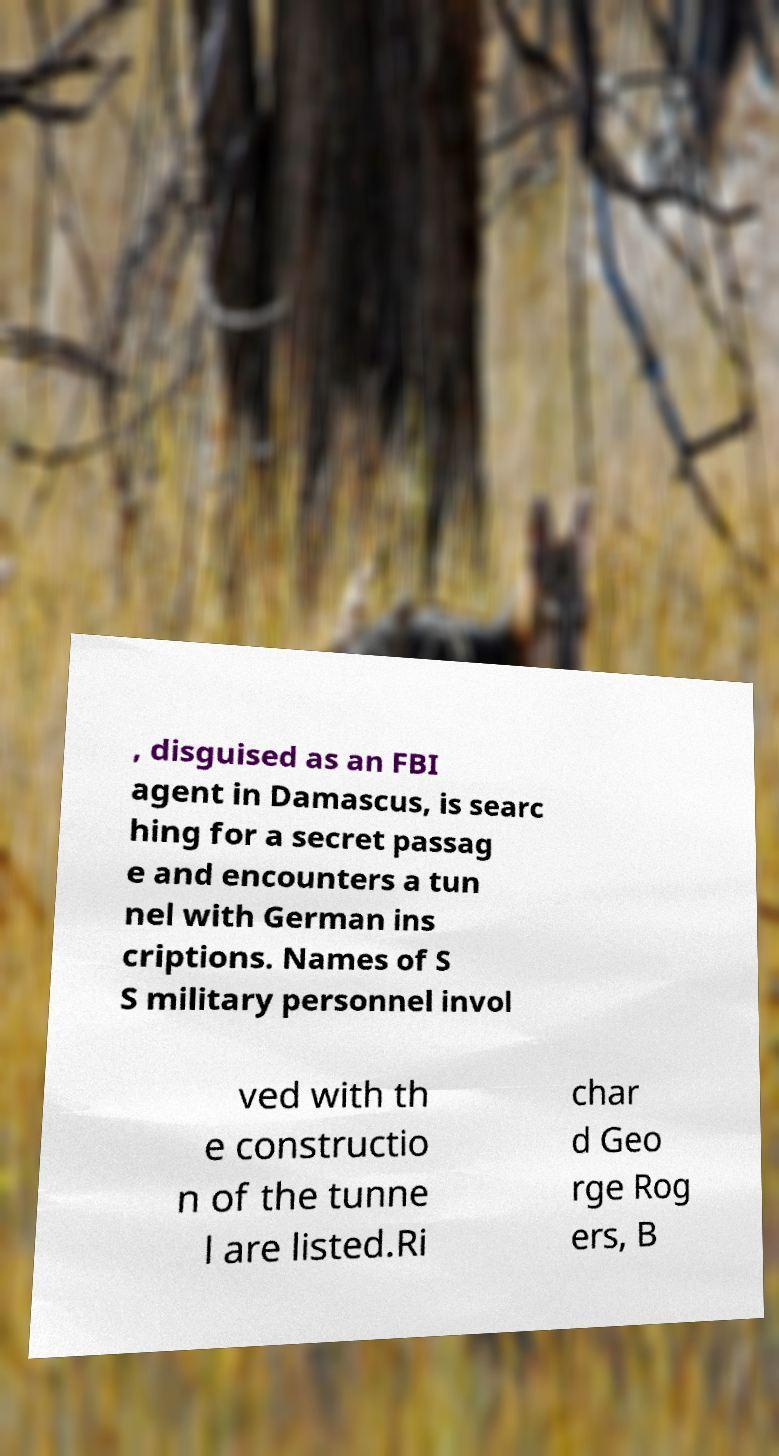Can you read and provide the text displayed in the image?This photo seems to have some interesting text. Can you extract and type it out for me? , disguised as an FBI agent in Damascus, is searc hing for a secret passag e and encounters a tun nel with German ins criptions. Names of S S military personnel invol ved with th e constructio n of the tunne l are listed.Ri char d Geo rge Rog ers, B 